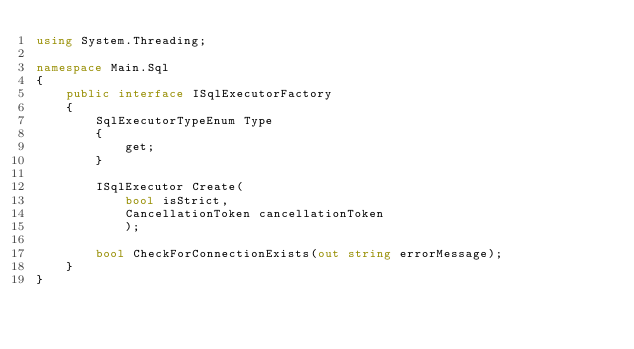<code> <loc_0><loc_0><loc_500><loc_500><_C#_>using System.Threading;

namespace Main.Sql
{
    public interface ISqlExecutorFactory
    {
        SqlExecutorTypeEnum Type
        {
            get;
        }

        ISqlExecutor Create(
            bool isStrict,
            CancellationToken cancellationToken
            );

        bool CheckForConnectionExists(out string errorMessage);
    }
}
</code> 